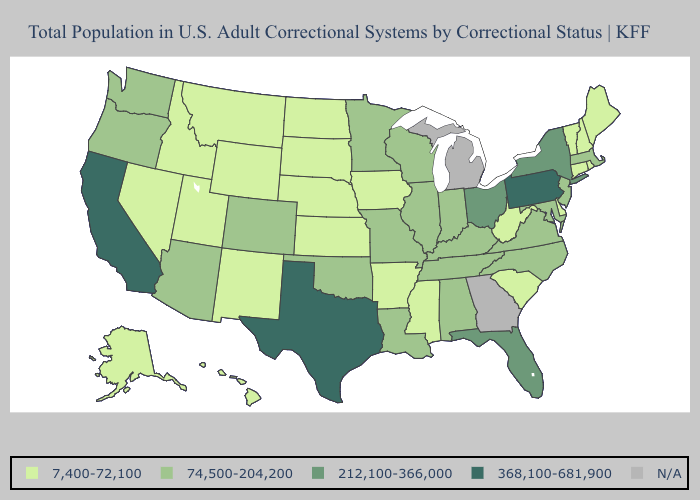What is the value of Nevada?
Short answer required. 7,400-72,100. Name the states that have a value in the range N/A?
Keep it brief. Georgia, Michigan. What is the value of Iowa?
Give a very brief answer. 7,400-72,100. Does the map have missing data?
Write a very short answer. Yes. Among the states that border North Dakota , which have the lowest value?
Concise answer only. Montana, South Dakota. Name the states that have a value in the range 7,400-72,100?
Give a very brief answer. Alaska, Arkansas, Connecticut, Delaware, Hawaii, Idaho, Iowa, Kansas, Maine, Mississippi, Montana, Nebraska, Nevada, New Hampshire, New Mexico, North Dakota, Rhode Island, South Carolina, South Dakota, Utah, Vermont, West Virginia, Wyoming. Does Louisiana have the lowest value in the South?
Be succinct. No. Name the states that have a value in the range 74,500-204,200?
Write a very short answer. Alabama, Arizona, Colorado, Illinois, Indiana, Kentucky, Louisiana, Maryland, Massachusetts, Minnesota, Missouri, New Jersey, North Carolina, Oklahoma, Oregon, Tennessee, Virginia, Washington, Wisconsin. Does Nebraska have the lowest value in the USA?
Keep it brief. Yes. What is the value of Alabama?
Answer briefly. 74,500-204,200. Name the states that have a value in the range 7,400-72,100?
Short answer required. Alaska, Arkansas, Connecticut, Delaware, Hawaii, Idaho, Iowa, Kansas, Maine, Mississippi, Montana, Nebraska, Nevada, New Hampshire, New Mexico, North Dakota, Rhode Island, South Carolina, South Dakota, Utah, Vermont, West Virginia, Wyoming. What is the highest value in states that border Nevada?
Keep it brief. 368,100-681,900. 